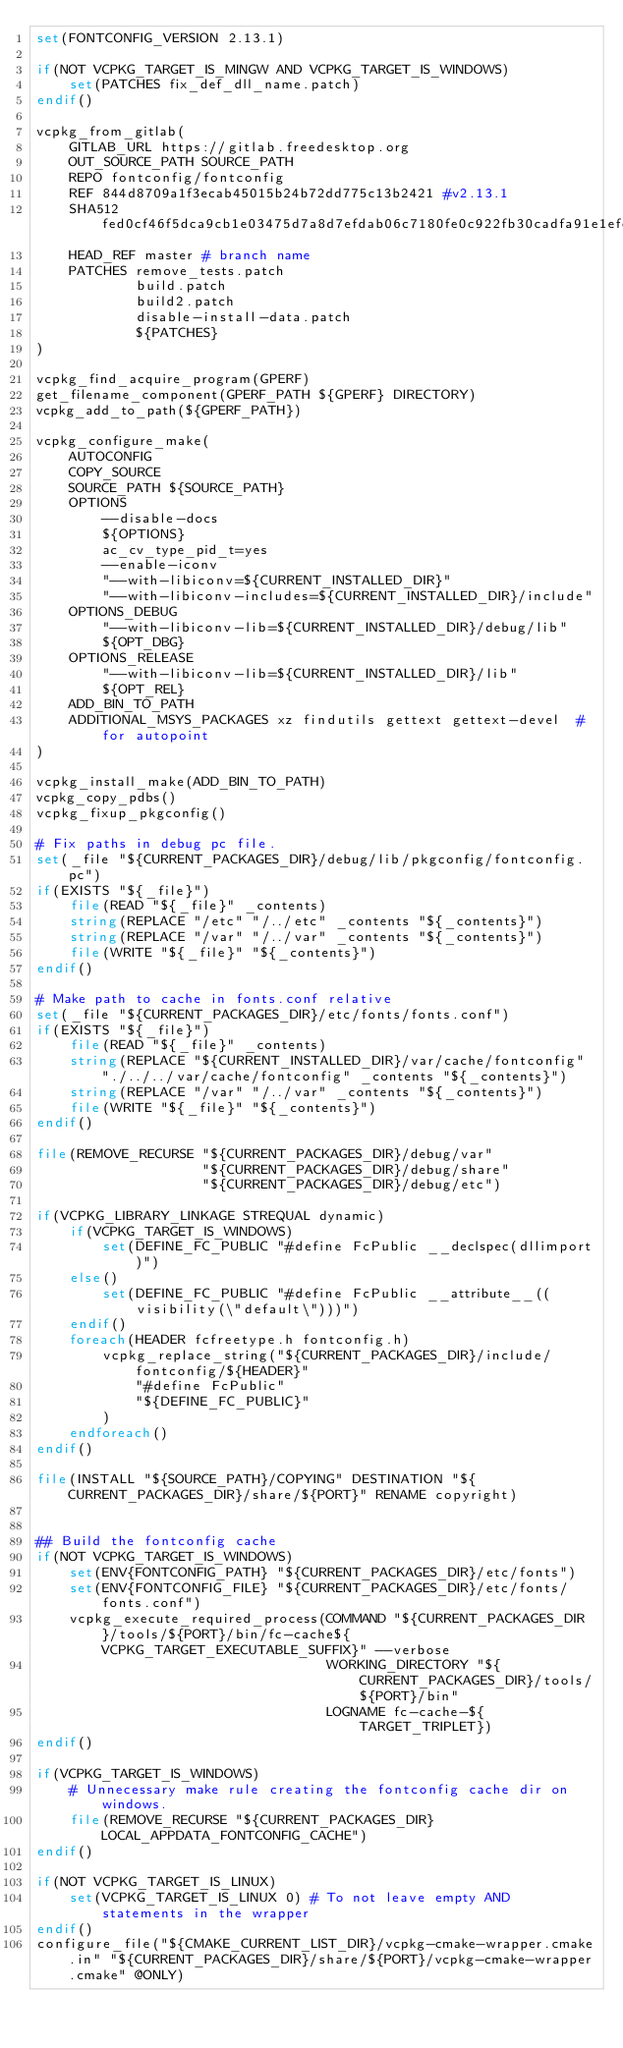<code> <loc_0><loc_0><loc_500><loc_500><_CMake_>set(FONTCONFIG_VERSION 2.13.1)

if(NOT VCPKG_TARGET_IS_MINGW AND VCPKG_TARGET_IS_WINDOWS)
    set(PATCHES fix_def_dll_name.patch)
endif()

vcpkg_from_gitlab(
    GITLAB_URL https://gitlab.freedesktop.org
    OUT_SOURCE_PATH SOURCE_PATH
    REPO fontconfig/fontconfig
    REF 844d8709a1f3ecab45015b24b72dd775c13b2421 #v2.13.1
    SHA512 fed0cf46f5dca9cb1e03475d7a8d7efdab06c7180fe0c922fb30cadfa91e1efe1f6a6e36d2fdb742a479cb09c05b0aefb5da5658bf2e01a32b7ac88ee8ff0b58
    HEAD_REF master # branch name
    PATCHES remove_tests.patch
            build.patch
            build2.patch
            disable-install-data.patch
            ${PATCHES}
)

vcpkg_find_acquire_program(GPERF)
get_filename_component(GPERF_PATH ${GPERF} DIRECTORY)
vcpkg_add_to_path(${GPERF_PATH})

vcpkg_configure_make(
    AUTOCONFIG
    COPY_SOURCE
    SOURCE_PATH ${SOURCE_PATH}
    OPTIONS
        --disable-docs
        ${OPTIONS}
        ac_cv_type_pid_t=yes
        --enable-iconv
        "--with-libiconv=${CURRENT_INSTALLED_DIR}"
        "--with-libiconv-includes=${CURRENT_INSTALLED_DIR}/include"
    OPTIONS_DEBUG
        "--with-libiconv-lib=${CURRENT_INSTALLED_DIR}/debug/lib"
        ${OPT_DBG}
    OPTIONS_RELEASE
        "--with-libiconv-lib=${CURRENT_INSTALLED_DIR}/lib"
        ${OPT_REL}
    ADD_BIN_TO_PATH
    ADDITIONAL_MSYS_PACKAGES xz findutils gettext gettext-devel  # for autopoint
)

vcpkg_install_make(ADD_BIN_TO_PATH)
vcpkg_copy_pdbs()
vcpkg_fixup_pkgconfig()

# Fix paths in debug pc file.
set(_file "${CURRENT_PACKAGES_DIR}/debug/lib/pkgconfig/fontconfig.pc")
if(EXISTS "${_file}")
    file(READ "${_file}" _contents)
    string(REPLACE "/etc" "/../etc" _contents "${_contents}")
    string(REPLACE "/var" "/../var" _contents "${_contents}")
    file(WRITE "${_file}" "${_contents}")
endif()

# Make path to cache in fonts.conf relative
set(_file "${CURRENT_PACKAGES_DIR}/etc/fonts/fonts.conf")
if(EXISTS "${_file}")
    file(READ "${_file}" _contents)
    string(REPLACE "${CURRENT_INSTALLED_DIR}/var/cache/fontconfig" "./../../var/cache/fontconfig" _contents "${_contents}")
    string(REPLACE "/var" "/../var" _contents "${_contents}")
    file(WRITE "${_file}" "${_contents}")
endif()

file(REMOVE_RECURSE "${CURRENT_PACKAGES_DIR}/debug/var"
                    "${CURRENT_PACKAGES_DIR}/debug/share"
                    "${CURRENT_PACKAGES_DIR}/debug/etc")

if(VCPKG_LIBRARY_LINKAGE STREQUAL dynamic)
    if(VCPKG_TARGET_IS_WINDOWS)
        set(DEFINE_FC_PUBLIC "#define FcPublic __declspec(dllimport)")
    else()
        set(DEFINE_FC_PUBLIC "#define FcPublic __attribute__((visibility(\"default\")))")
    endif()
    foreach(HEADER fcfreetype.h fontconfig.h)
        vcpkg_replace_string("${CURRENT_PACKAGES_DIR}/include/fontconfig/${HEADER}"
            "#define FcPublic"
            "${DEFINE_FC_PUBLIC}"
        )
    endforeach()
endif()

file(INSTALL "${SOURCE_PATH}/COPYING" DESTINATION "${CURRENT_PACKAGES_DIR}/share/${PORT}" RENAME copyright)


## Build the fontconfig cache
if(NOT VCPKG_TARGET_IS_WINDOWS)
    set(ENV{FONTCONFIG_PATH} "${CURRENT_PACKAGES_DIR}/etc/fonts")
    set(ENV{FONTCONFIG_FILE} "${CURRENT_PACKAGES_DIR}/etc/fonts/fonts.conf")
    vcpkg_execute_required_process(COMMAND "${CURRENT_PACKAGES_DIR}/tools/${PORT}/bin/fc-cache${VCPKG_TARGET_EXECUTABLE_SUFFIX}" --verbose
                                   WORKING_DIRECTORY "${CURRENT_PACKAGES_DIR}/tools/${PORT}/bin"
                                   LOGNAME fc-cache-${TARGET_TRIPLET})
endif()

if(VCPKG_TARGET_IS_WINDOWS)
    # Unnecessary make rule creating the fontconfig cache dir on windows. 
    file(REMOVE_RECURSE "${CURRENT_PACKAGES_DIR}LOCAL_APPDATA_FONTCONFIG_CACHE")
endif()

if(NOT VCPKG_TARGET_IS_LINUX)
    set(VCPKG_TARGET_IS_LINUX 0) # To not leave empty AND statements in the wrapper
endif()
configure_file("${CMAKE_CURRENT_LIST_DIR}/vcpkg-cmake-wrapper.cmake.in" "${CURRENT_PACKAGES_DIR}/share/${PORT}/vcpkg-cmake-wrapper.cmake" @ONLY)
</code> 